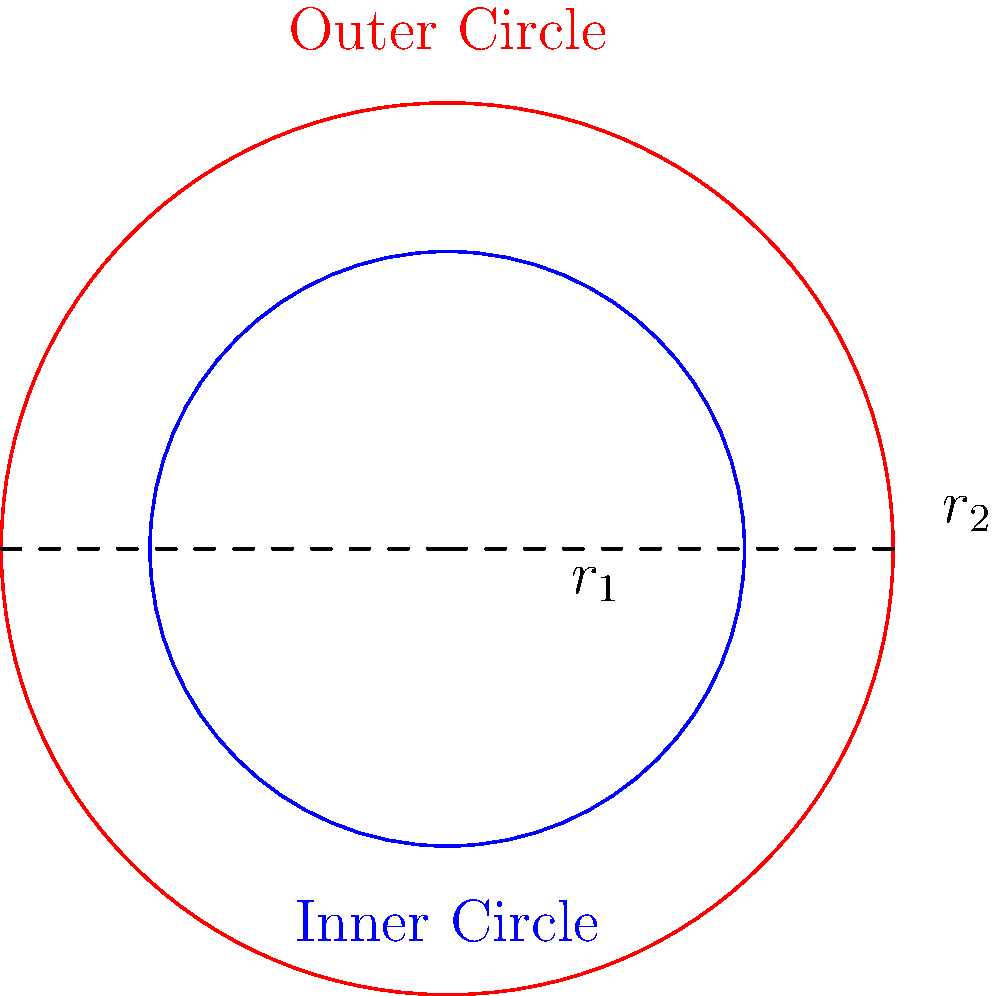In the diagram above, two concentric circles represent the inner and outer spiritual growth of a nurse. The radius of the inner circle is $r_1$ and the radius of the outer circle is $r_2$. If the area of the outer circle is 2.25 times the area of the inner circle, what is the ratio of $r_2$ to $r_1$? Let's approach this step-by-step:

1) The area of a circle is given by the formula $A = \pi r^2$, where $r$ is the radius.

2) Let's denote the area of the inner circle as $A_1$ and the area of the outer circle as $A_2$.

3) We're told that $A_2 = 2.25 A_1$

4) We can express this in terms of the radii:
   $\pi r_2^2 = 2.25 \pi r_1^2$

5) The $\pi$ cancels out on both sides:
   $r_2^2 = 2.25 r_1^2$

6) To find the ratio of $r_2$ to $r_1$, we need to take the square root of both sides:
   $\sqrt{r_2^2} = \sqrt{2.25 r_1^2}$
   $r_2 = \sqrt{2.25} r_1$

7) $\sqrt{2.25} = 1.5$

Therefore, the ratio of $r_2$ to $r_1$ is 1.5 to 1, or simply 1.5.

This ratio symbolizes that as the nurse's outer spiritual growth (represented by $r_2$) expands, it maintains a proportional relationship with her inner spiritual core (represented by $r_1$).
Answer: 1.5 